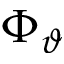Convert formula to latex. <formula><loc_0><loc_0><loc_500><loc_500>\Phi _ { \vartheta }</formula> 